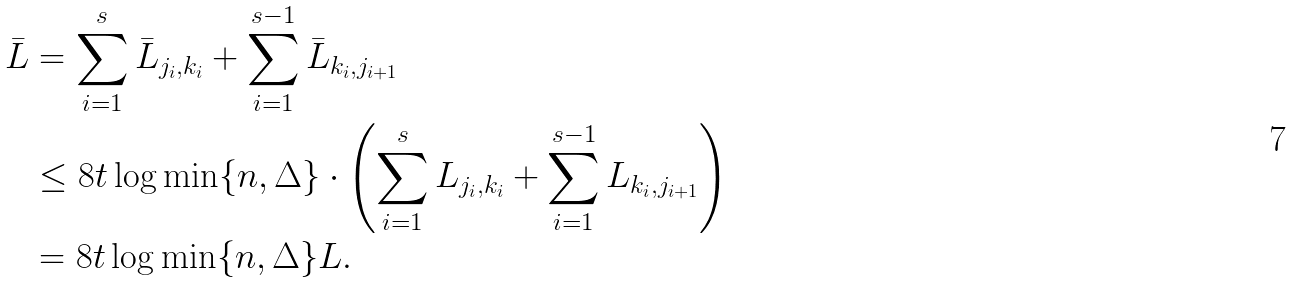Convert formula to latex. <formula><loc_0><loc_0><loc_500><loc_500>\bar { L } & = \sum _ { i = 1 } ^ { s } \bar { L } _ { j _ { i } , k _ { i } } + \sum _ { i = 1 } ^ { s - 1 } \bar { L } _ { k _ { i } , j _ { i + 1 } } \\ & \leq 8 t \log \min \{ n , \Delta \} \cdot \left ( \sum _ { i = 1 } ^ { s } L _ { j _ { i } , k _ { i } } + \sum _ { i = 1 } ^ { s - 1 } L _ { k _ { i } , j _ { i + 1 } } \right ) \\ & = 8 t \log \min \{ n , \Delta \} L .</formula> 